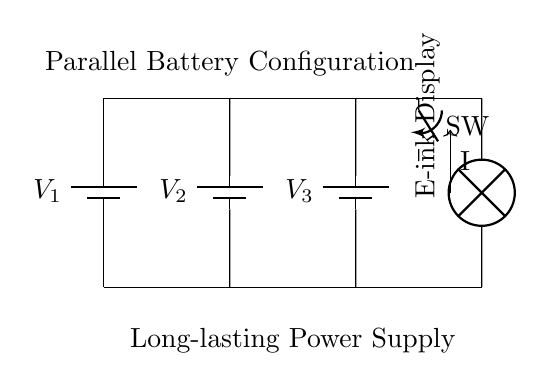What is the total number of batteries in the configuration? The diagram shows three batteries, labeled V1, V2, and V3, connected in parallel. These represent the total number of batteries in this configuration.
Answer: three What type of load is present in the circuit? The circuit includes an E-ink display, which is indicated by the component labeled in the diagram. An E-ink display is known for its low power consumption and is commonly used in e-readers.
Answer: E-ink Display What is the significance of the parallel configuration? The parallel configuration allows all batteries to provide the same voltage while increasing total capacity (amp-hours). Therefore, by connecting them in parallel, we enhance the overall energy storage and long-lasting power supply.
Answer: long-lasting power supply What component is used to control the flow of current in the circuit? The circuit diagram features a switch, labeled as SW, which is used to open or close the circuit. By manipulating the switch, one can control whether the current flows to the load or not.
Answer: switch How is current directed in this circuit? The direction of current flow is indicated by an arrow labeled I, which shows that the current moves from the batteries towards the E-ink display. In a parallel configuration, the current can be derived from any of the batteries simultaneously to power the load.
Answer: from batteries to load What is the overall function of the batteries in this configuration? The purpose of the batteries in parallel is to supply power to the E-ink display. By connecting several batteries together, the circuit ensures a stable voltage and greater capacity, thus allowing the display to function efficiently for extended periods.
Answer: power supply 